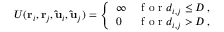<formula> <loc_0><loc_0><loc_500><loc_500>\begin{array} { r } { U ( r _ { i } , r _ { j } , \hat { u } _ { i } , \hat { u } _ { j } ) = \left \{ \begin{array} { l l } { \infty } & { f o r d _ { i , j } \leq D \, , } \\ { 0 } & { f o r d _ { i , j } > D \, , } \end{array} } \end{array}</formula> 